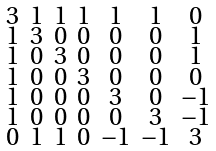<formula> <loc_0><loc_0><loc_500><loc_500>\begin{smallmatrix} 3 & 1 & 1 & 1 & 1 & 1 & 0 \\ 1 & 3 & 0 & 0 & 0 & 0 & 1 \\ 1 & 0 & 3 & 0 & 0 & 0 & 1 \\ 1 & 0 & 0 & 3 & 0 & 0 & 0 \\ 1 & 0 & 0 & 0 & 3 & 0 & - 1 \\ 1 & 0 & 0 & 0 & 0 & 3 & - 1 \\ 0 & 1 & 1 & 0 & - 1 & - 1 & 3 \end{smallmatrix}</formula> 